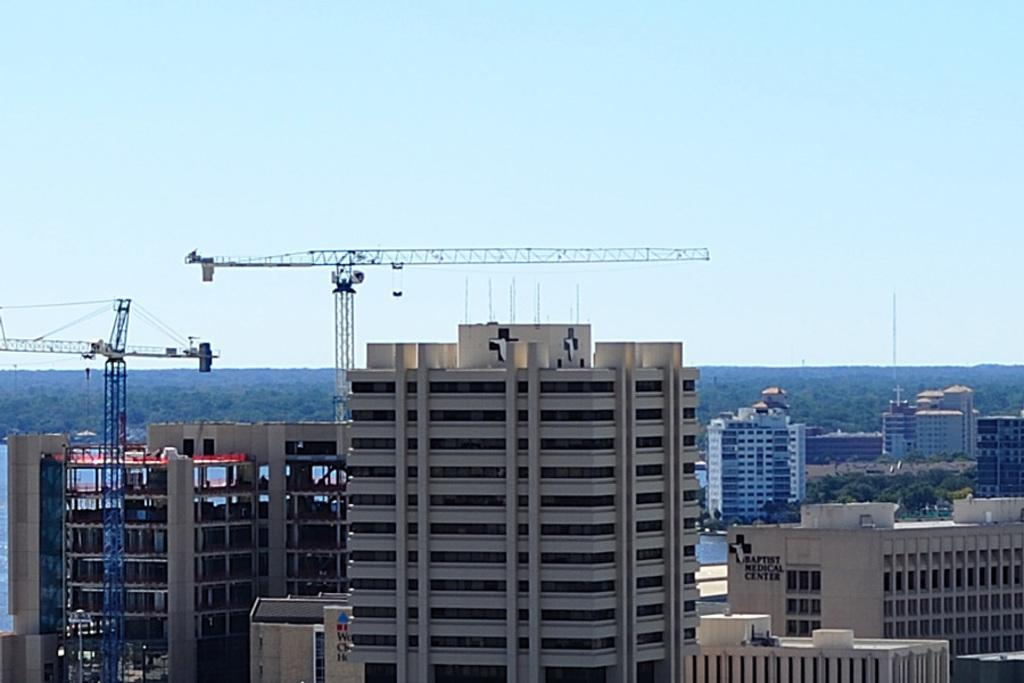What is the setting of the image? The image has an outside view. What can be seen in the foreground of the image? There are buildings in the foreground of the image. What is located on the left side of the image? There are cranes on the left side of the image. What is visible in the background of the image? There is a sky visible in the background of the image. Can you see a rifle being used by someone in the image? There is no rifle present in the image. Are there any yaks visible in the image? There are no yaks present in the image. 